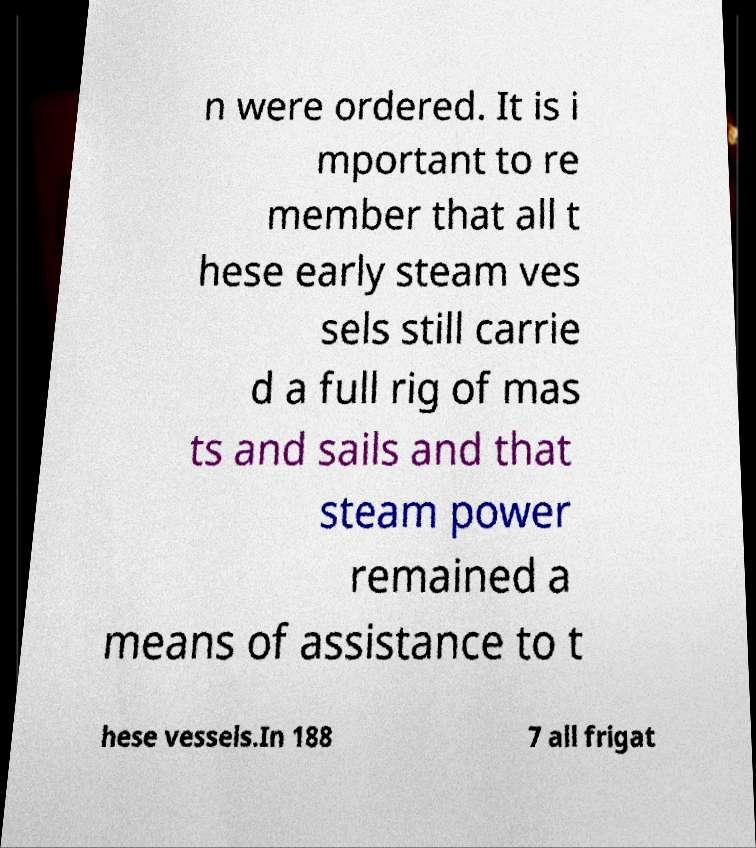Can you accurately transcribe the text from the provided image for me? n were ordered. It is i mportant to re member that all t hese early steam ves sels still carrie d a full rig of mas ts and sails and that steam power remained a means of assistance to t hese vessels.In 188 7 all frigat 